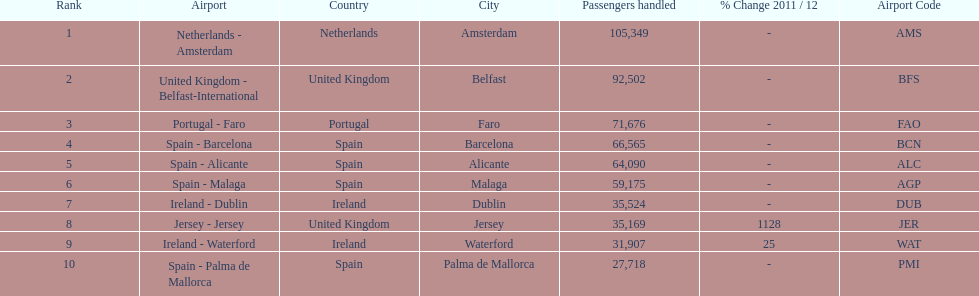How many airports in spain are among the 10 busiest routes to and from london southend airport in 2012? 4. 